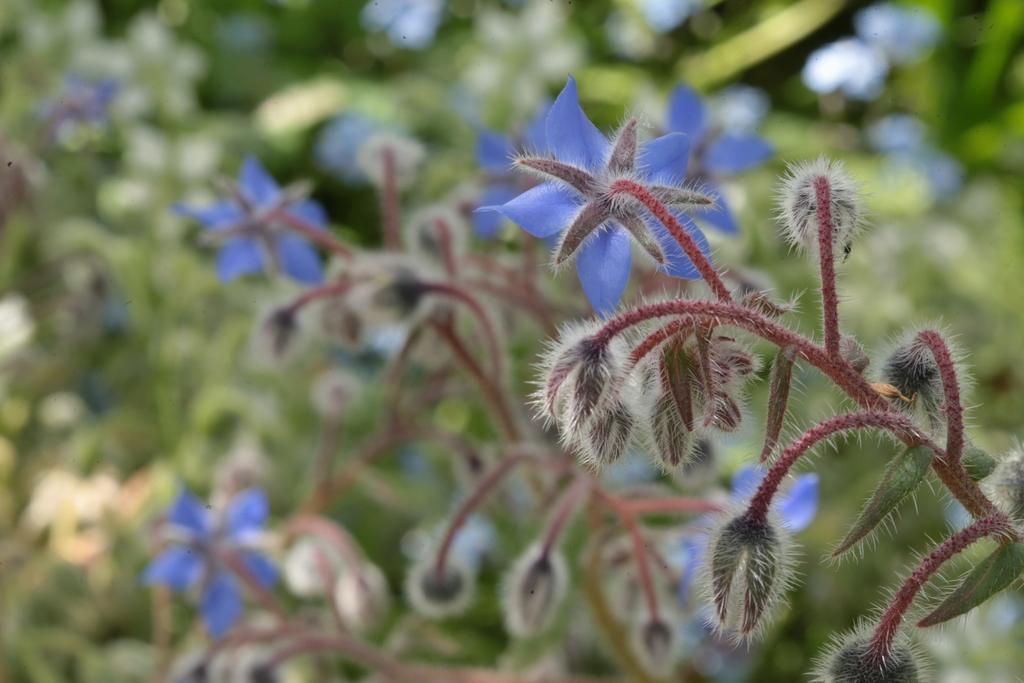How would you summarize this image in a sentence or two? In the foreground of this picture, there is a purple flower to a plant and there are few buds to it. In the background, there are plants. 